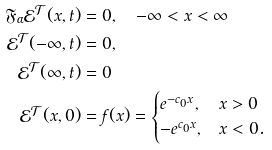<formula> <loc_0><loc_0><loc_500><loc_500>\mathfrak { F } _ { \alpha } \mathcal { E } ^ { \mathcal { T } } ( x , t ) & = 0 , \quad - \infty < x < \infty \\ \mathcal { E } ^ { \mathcal { T } } ( - \infty , t ) & = 0 , \\ \mathcal { E } ^ { \mathcal { T } } ( \infty , t ) & = 0 \\ \mathcal { E } ^ { \mathcal { T } } ( x , 0 ) & = f ( x ) = \begin{cases} e ^ { - c _ { 0 } x } , & x > 0 \\ - e ^ { c _ { 0 } x } , & x < 0 . \end{cases}</formula> 